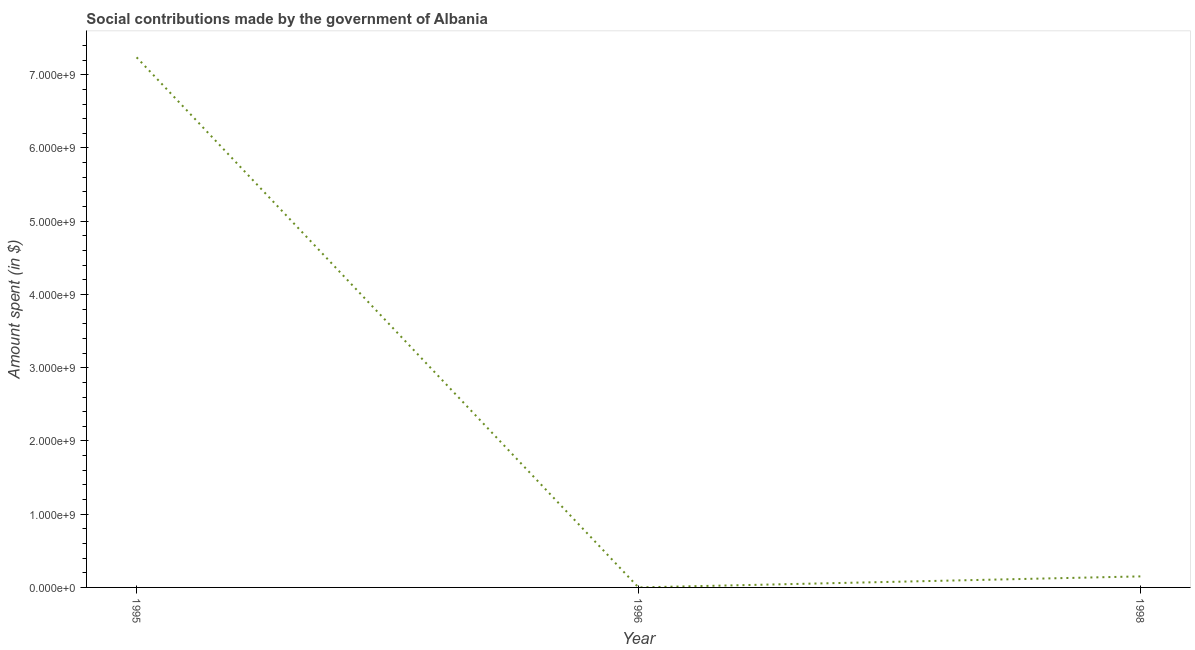What is the amount spent in making social contributions in 1998?
Give a very brief answer. 1.51e+08. Across all years, what is the maximum amount spent in making social contributions?
Provide a succinct answer. 7.24e+09. Across all years, what is the minimum amount spent in making social contributions?
Your answer should be compact. 2000. What is the sum of the amount spent in making social contributions?
Keep it short and to the point. 7.39e+09. What is the difference between the amount spent in making social contributions in 1996 and 1998?
Offer a terse response. -1.51e+08. What is the average amount spent in making social contributions per year?
Offer a very short reply. 2.46e+09. What is the median amount spent in making social contributions?
Provide a succinct answer. 1.51e+08. In how many years, is the amount spent in making social contributions greater than 2200000000 $?
Offer a very short reply. 1. Do a majority of the years between 1998 and 1996 (inclusive) have amount spent in making social contributions greater than 4200000000 $?
Your answer should be very brief. No. What is the ratio of the amount spent in making social contributions in 1995 to that in 1996?
Provide a short and direct response. 3.62e+06. What is the difference between the highest and the second highest amount spent in making social contributions?
Provide a short and direct response. 7.09e+09. Is the sum of the amount spent in making social contributions in 1995 and 1996 greater than the maximum amount spent in making social contributions across all years?
Your answer should be compact. Yes. What is the difference between the highest and the lowest amount spent in making social contributions?
Your answer should be very brief. 7.24e+09. In how many years, is the amount spent in making social contributions greater than the average amount spent in making social contributions taken over all years?
Make the answer very short. 1. What is the difference between two consecutive major ticks on the Y-axis?
Your answer should be very brief. 1.00e+09. Does the graph contain any zero values?
Give a very brief answer. No. What is the title of the graph?
Give a very brief answer. Social contributions made by the government of Albania. What is the label or title of the Y-axis?
Your answer should be very brief. Amount spent (in $). What is the Amount spent (in $) in 1995?
Provide a succinct answer. 7.24e+09. What is the Amount spent (in $) of 1998?
Ensure brevity in your answer.  1.51e+08. What is the difference between the Amount spent (in $) in 1995 and 1996?
Provide a succinct answer. 7.24e+09. What is the difference between the Amount spent (in $) in 1995 and 1998?
Keep it short and to the point. 7.09e+09. What is the difference between the Amount spent (in $) in 1996 and 1998?
Offer a very short reply. -1.51e+08. What is the ratio of the Amount spent (in $) in 1995 to that in 1996?
Ensure brevity in your answer.  3.62e+06. What is the ratio of the Amount spent (in $) in 1995 to that in 1998?
Make the answer very short. 48.03. What is the ratio of the Amount spent (in $) in 1996 to that in 1998?
Offer a terse response. 0. 